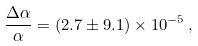Convert formula to latex. <formula><loc_0><loc_0><loc_500><loc_500>\frac { \Delta \alpha } { \alpha } = ( 2 . 7 \pm 9 . 1 ) \times 1 0 ^ { - 5 } \, ,</formula> 